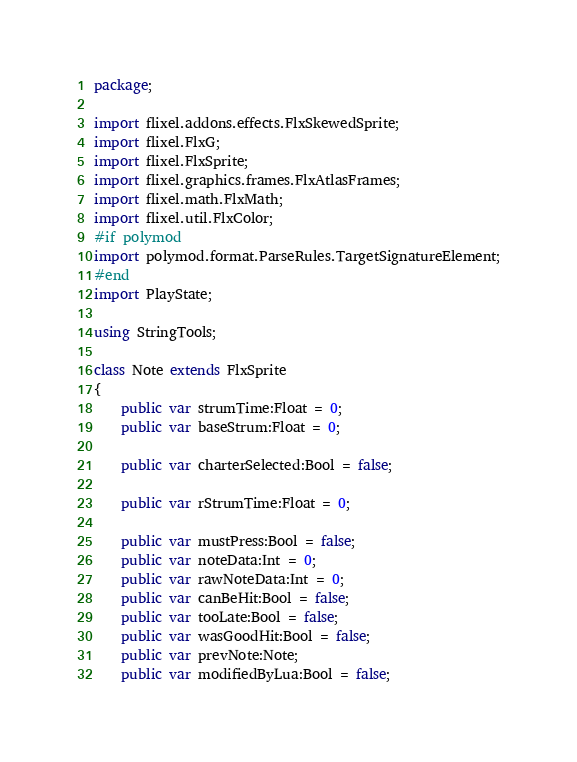Convert code to text. <code><loc_0><loc_0><loc_500><loc_500><_Haxe_>package;

import flixel.addons.effects.FlxSkewedSprite;
import flixel.FlxG;
import flixel.FlxSprite;
import flixel.graphics.frames.FlxAtlasFrames;
import flixel.math.FlxMath;
import flixel.util.FlxColor;
#if polymod
import polymod.format.ParseRules.TargetSignatureElement;
#end
import PlayState;

using StringTools;

class Note extends FlxSprite
{
	public var strumTime:Float = 0;
	public var baseStrum:Float = 0;

	public var charterSelected:Bool = false;

	public var rStrumTime:Float = 0;

	public var mustPress:Bool = false;
	public var noteData:Int = 0;
	public var rawNoteData:Int = 0;
	public var canBeHit:Bool = false;
	public var tooLate:Bool = false;
	public var wasGoodHit:Bool = false;
	public var prevNote:Note;
	public var modifiedByLua:Bool = false;</code> 